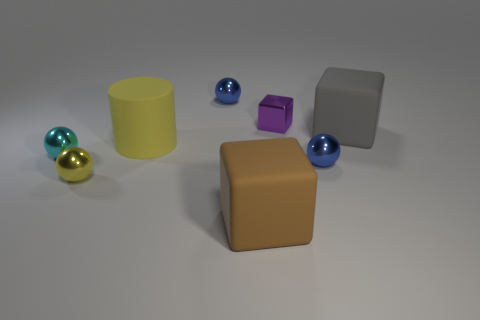What material is the large cube right of the matte thing in front of the cyan sphere?
Give a very brief answer. Rubber. There is a rubber object that is in front of the small yellow metal ball; is it the same shape as the large rubber thing that is right of the big brown matte thing?
Offer a terse response. Yes. There is a small thing that is the same color as the cylinder; what is its shape?
Your answer should be very brief. Sphere. How many small cyan objects are the same material as the large yellow cylinder?
Your response must be concise. 0. There is a object that is behind the yellow cylinder and right of the small purple metallic thing; what shape is it?
Offer a very short reply. Cube. Is the material of the ball behind the small cyan object the same as the cyan thing?
Your answer should be very brief. Yes. What color is the matte cube that is the same size as the gray thing?
Your answer should be very brief. Brown. Are there any metallic objects of the same color as the large matte cylinder?
Ensure brevity in your answer.  Yes. There is a gray block that is made of the same material as the big yellow thing; what size is it?
Your answer should be compact. Large. How many other objects are the same size as the purple metallic block?
Make the answer very short. 4. 